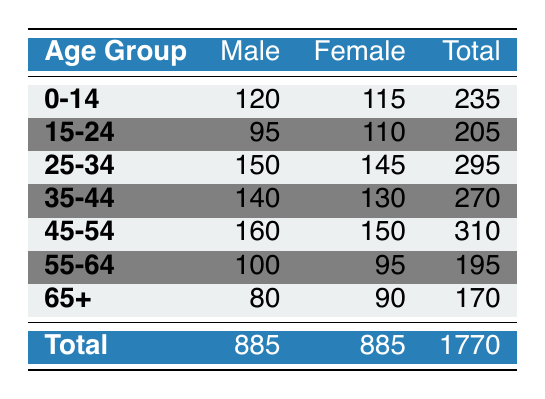What is the male population in the age group 25-34? The table lists the male population for each age group, and for the age group 25-34, it shows a male population of 150.
Answer: 150 What is the total population of the Village of Hopkins? To find the total population, refer to the last row of the table where the total for all age groups is listed as 1770.
Answer: 1770 How many more females are there than males in the age group 65+? For the age group 65+, the male population is 80 and the female population is 90; the difference is 90 - 80 = 10.
Answer: 10 What is the total female population across all age groups? The table shows that the total female population is 885, which is noted in the totals row alongside the male population.
Answer: 885 In which age group do males and females have the same total population? The table does not show any individual age group where the male and female populations are equal, but the overall total population of males and females is equal at 885.
Answer: None How many males are there in the age group 45-54 compared to the 55-64 age group? The 45-54 age group has 160 males and the 55-64 age group has 100 males; the difference is 160 - 100 = 60, indicating there are 60 more males in the 45-54 age group.
Answer: 60 What is the average population of each age group? There are 7 age groups listed. The sum of the total populations is 1770. The average is calculated by 1770 divided by 7, which gives approximately 252.86, or 253 when rounded.
Answer: Approximately 253 Which age group has the highest total population? By examining the total populations, the age group 45-54 has the highest total population of 310 compared to other age groups.
Answer: 45-54 Is the male population in the age group 15-24 greater than the male population in the age group 55-64? The male population in 15-24 is 95 and in the 55-64 age group it is 100; therefore, 95 is not greater than 100, making the statement false.
Answer: No How many residents aged 35-44 and 45-54 are there combined? The total for the 35-44 age group is 270 and for 45-54 is 310. Combining them gives 270 + 310 = 580.
Answer: 580 